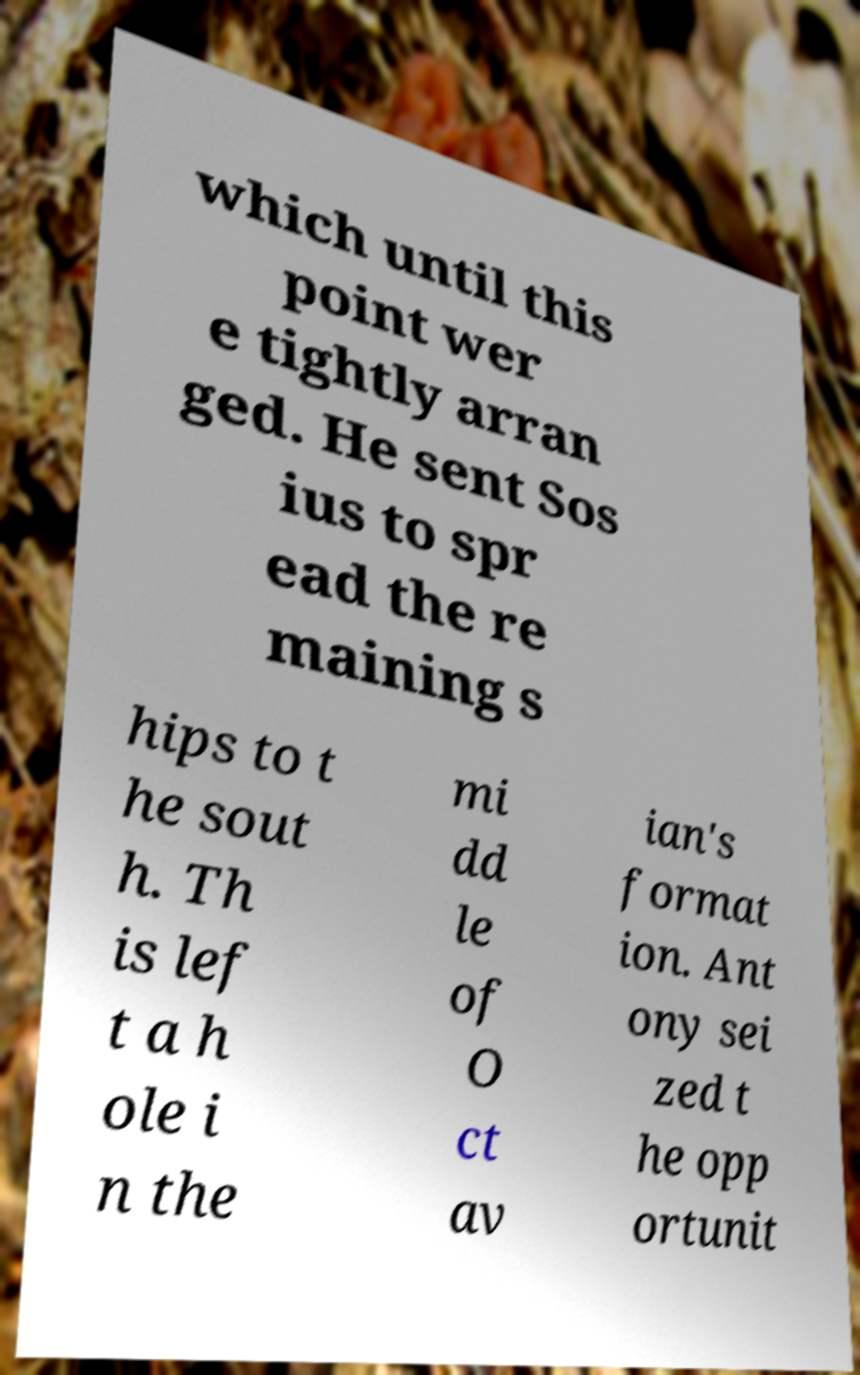Please identify and transcribe the text found in this image. which until this point wer e tightly arran ged. He sent Sos ius to spr ead the re maining s hips to t he sout h. Th is lef t a h ole i n the mi dd le of O ct av ian's format ion. Ant ony sei zed t he opp ortunit 